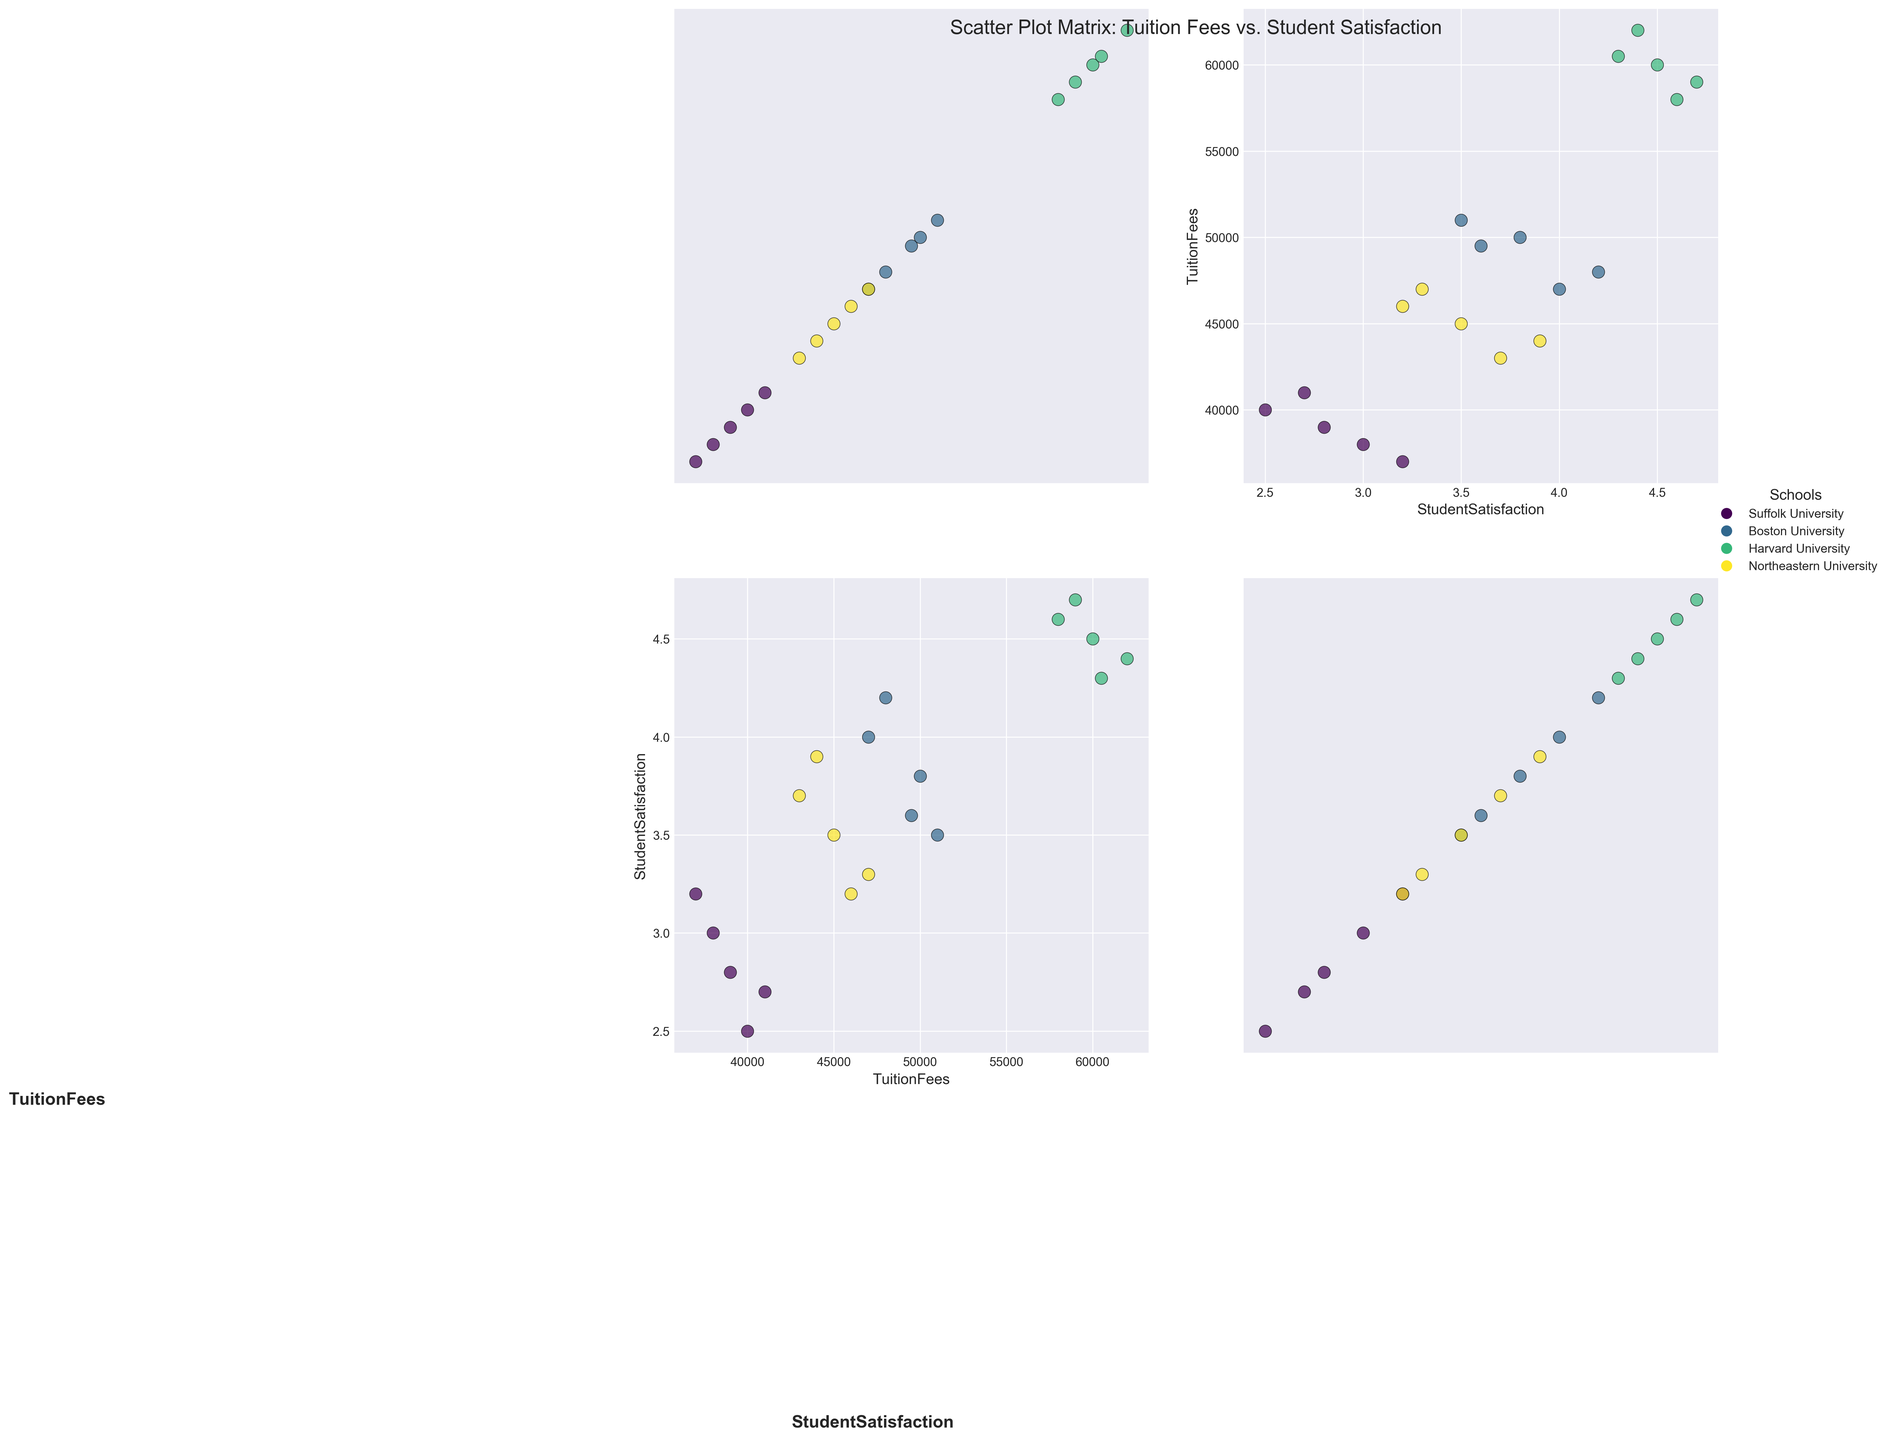What is the title of the scatter plot matrix? The title is typically positioned at the top center of the plot. One can see "Scatter Plot Matrix: Tuition Fees vs. Student Satisfaction" in that location.
Answer: Scatter Plot Matrix: Tuition Fees vs. Student Satisfaction How many unique schools are included in the scatter plot matrix? Each school has a unique color in the legend. By counting the unique color labels in the legend, we can see there are four: Suffolk University, Boston University, Harvard University, and Northeastern University.
Answer: Four (4) What color represents Suffolk University on the scatter plot matrix? The legend in the plot provides a color representation for each school. Suffolk University has a specific color assigned to it, identified as different from the other schools.
Answer: [Color specific to Suffolk University, indicated in the legend] Which school has the highest tuition fees according to the plot? By examining the scatter points on the plot with the highest values along the 'TuitionFees' axis, one can identify the school as indicated by its color in the legend.
Answer: Harvard University Where does Suffolk University stand in terms of student satisfaction for the Computer Science major? Locate the points for Suffolk University on the 'Student Satisfaction' vs. 'Tuition Fees' plot, focusing on the coordinates related to the Computer Science major. Compare it to other points.
Answer: 3.0 Which major at Harvard University has the highest student satisfaction? Identify the points colored for Harvard University and then look at the 'Student Satisfaction' values to find the highest among them for each major.
Answer: Computer Science Comparing Suffolk University and Boston University, which has higher student satisfaction for the Business Administration major? Locate the points for Business Administration for both Suffolk University and Boston University on the 'Student Satisfaction' axis, and compare their values.
Answer: Boston University What is the average student satisfaction for Northeastern University across all majors? Find all the points for Northeastern University on the scatter plots, sum their 'Student Satisfaction' values, and divide by the number of majors (5).
Answer: Average of (3.5, 3.9, 3.7, 3.2, 3.3) Is there an overall trend between tuition fees and student satisfaction among the universities? By looking at the general slopes or dispersion of scatter points across all school colors on the scatter plots, you can infer a trend. Typically, higher tuition fees might correlate with higher satisfaction.
Answer: Generally, higher tuition fees correlate with higher student satisfaction Which school shows the greatest variation in student satisfaction across different majors? Examine the range (highest minus lowest) of 'Student Satisfaction' values for each school's points. See which school has the largest range.
Answer: Suffolk University 